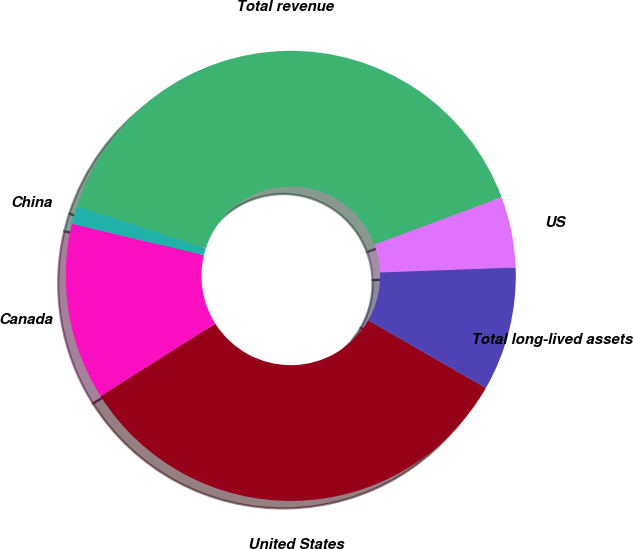Convert chart to OTSL. <chart><loc_0><loc_0><loc_500><loc_500><pie_chart><fcel>United States<fcel>Canada<fcel>China<fcel>Total revenue<fcel>US<fcel>Total long-lived assets<nl><fcel>32.73%<fcel>12.69%<fcel>1.29%<fcel>39.31%<fcel>5.09%<fcel>8.89%<nl></chart> 